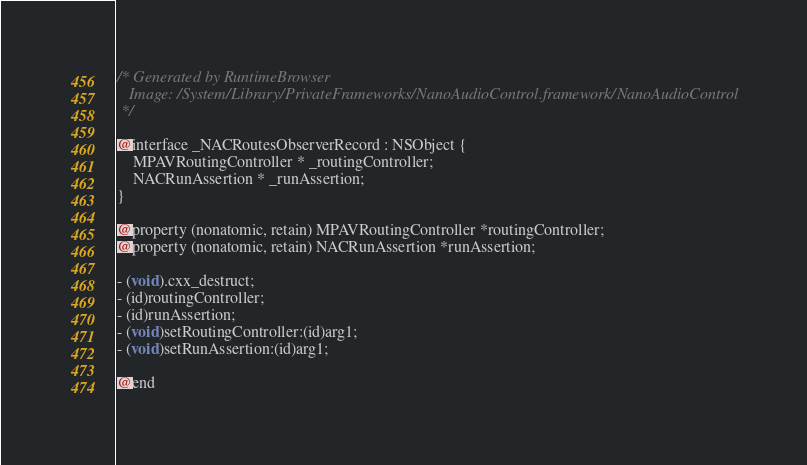<code> <loc_0><loc_0><loc_500><loc_500><_C_>/* Generated by RuntimeBrowser
   Image: /System/Library/PrivateFrameworks/NanoAudioControl.framework/NanoAudioControl
 */

@interface _NACRoutesObserverRecord : NSObject {
    MPAVRoutingController * _routingController;
    NACRunAssertion * _runAssertion;
}

@property (nonatomic, retain) MPAVRoutingController *routingController;
@property (nonatomic, retain) NACRunAssertion *runAssertion;

- (void).cxx_destruct;
- (id)routingController;
- (id)runAssertion;
- (void)setRoutingController:(id)arg1;
- (void)setRunAssertion:(id)arg1;

@end
</code> 